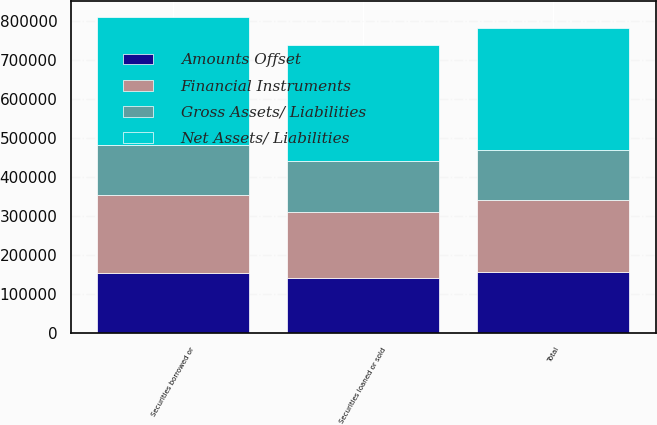Convert chart to OTSL. <chart><loc_0><loc_0><loc_500><loc_500><stacked_bar_chart><ecel><fcel>Securities borrowed or<fcel>Securities loaned or sold<fcel>Total<nl><fcel>Net Assets/ Liabilities<fcel>326970<fcel>299028<fcel>313476<nl><fcel>Gross Assets/ Liabilities<fcel>128746<fcel>128746<fcel>128746<nl><fcel>Financial Instruments<fcel>198224<fcel>170282<fcel>184730<nl><fcel>Amounts Offset<fcel>154974<fcel>140774<fcel>155222<nl></chart> 